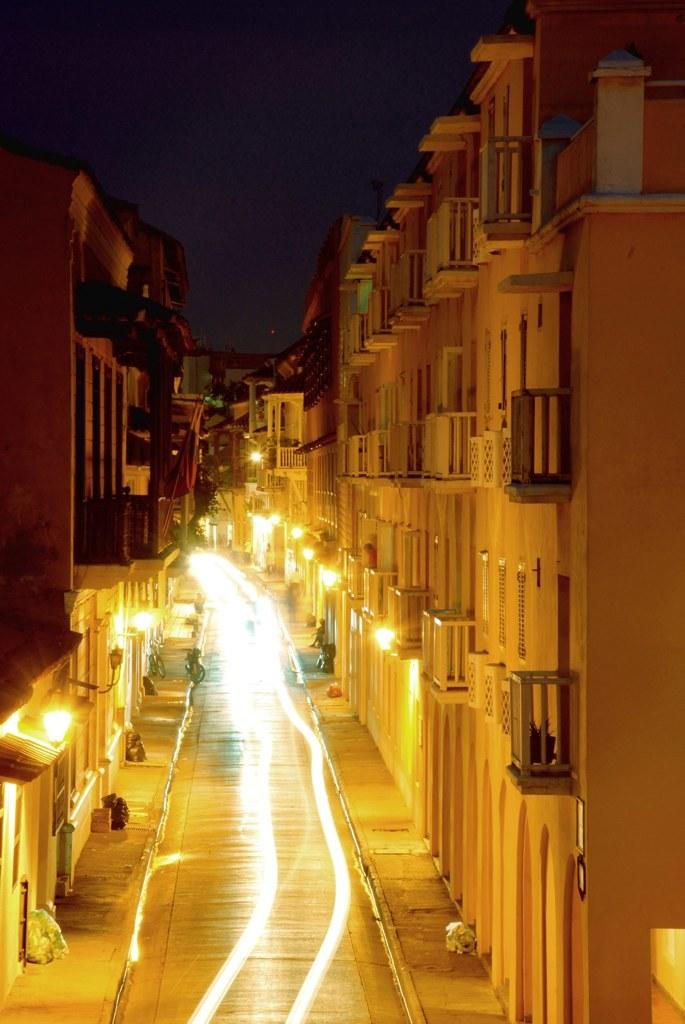What part of the natural environment is visible in the image? The sky is visible in the image. What type of man-made structures can be seen in the image? There are buildings in the image. What other objects can be seen in the image besides buildings? There are objects in the image. What might be used for illumination in the image? There are lights in the image. What type of surface is visible in the image? There is a pathway in the image. What language is spoken by the boat in the image? There is no boat present in the image, so it is not possible to determine what language might be spoken by a boat. 